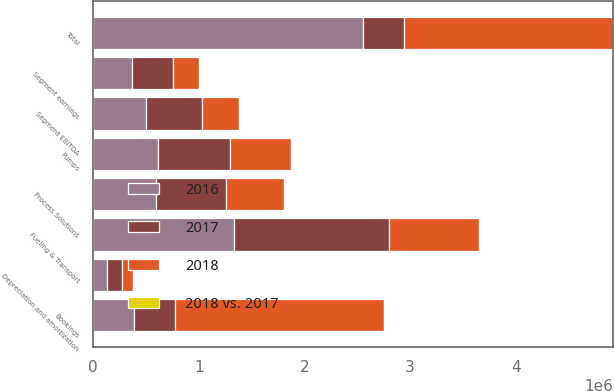Convert chart to OTSL. <chart><loc_0><loc_0><loc_500><loc_500><stacked_bar_chart><ecel><fcel>Fueling & Transport<fcel>Pumps<fcel>Process Solutions<fcel>Total<fcel>Segment earnings<fcel>Segment EBITDA<fcel>Depreciation and amortization<fcel>Bookings<nl><fcel>2017<fcel>1.46559e+06<fcel>676027<fcel>655721<fcel>389804<fcel>389804<fcel>530248<fcel>140444<fcel>389804<nl><fcel>2016<fcel>1.33806e+06<fcel>618224<fcel>598779<fcel>2.55506e+06<fcel>368630<fcel>504451<fcel>135821<fcel>389804<nl><fcel>2018<fcel>848109<fcel>577048<fcel>551893<fcel>1.97705e+06<fcel>246545<fcel>347811<fcel>101266<fcel>1.97043e+06<nl><fcel>2018 vs. 2017<fcel>9.5<fcel>9.3<fcel>9.5<fcel>9.5<fcel>5.7<fcel>5.1<fcel>3.4<fcel>11<nl></chart> 